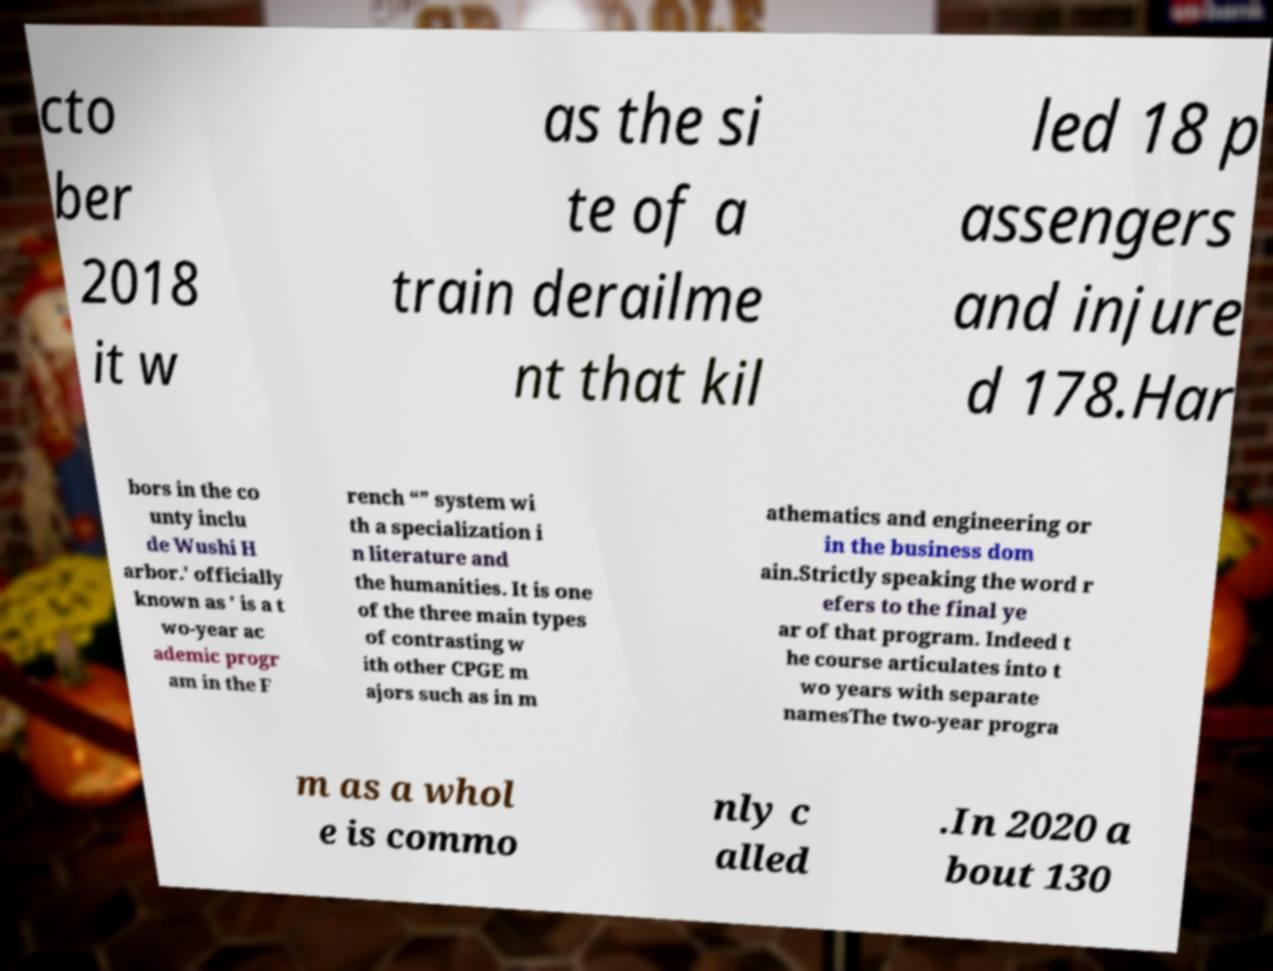For documentation purposes, I need the text within this image transcribed. Could you provide that? cto ber 2018 it w as the si te of a train derailme nt that kil led 18 p assengers and injure d 178.Har bors in the co unty inclu de Wushi H arbor.' officially known as ' is a t wo-year ac ademic progr am in the F rench “” system wi th a specialization i n literature and the humanities. It is one of the three main types of contrasting w ith other CPGE m ajors such as in m athematics and engineering or in the business dom ain.Strictly speaking the word r efers to the final ye ar of that program. Indeed t he course articulates into t wo years with separate namesThe two-year progra m as a whol e is commo nly c alled .In 2020 a bout 130 